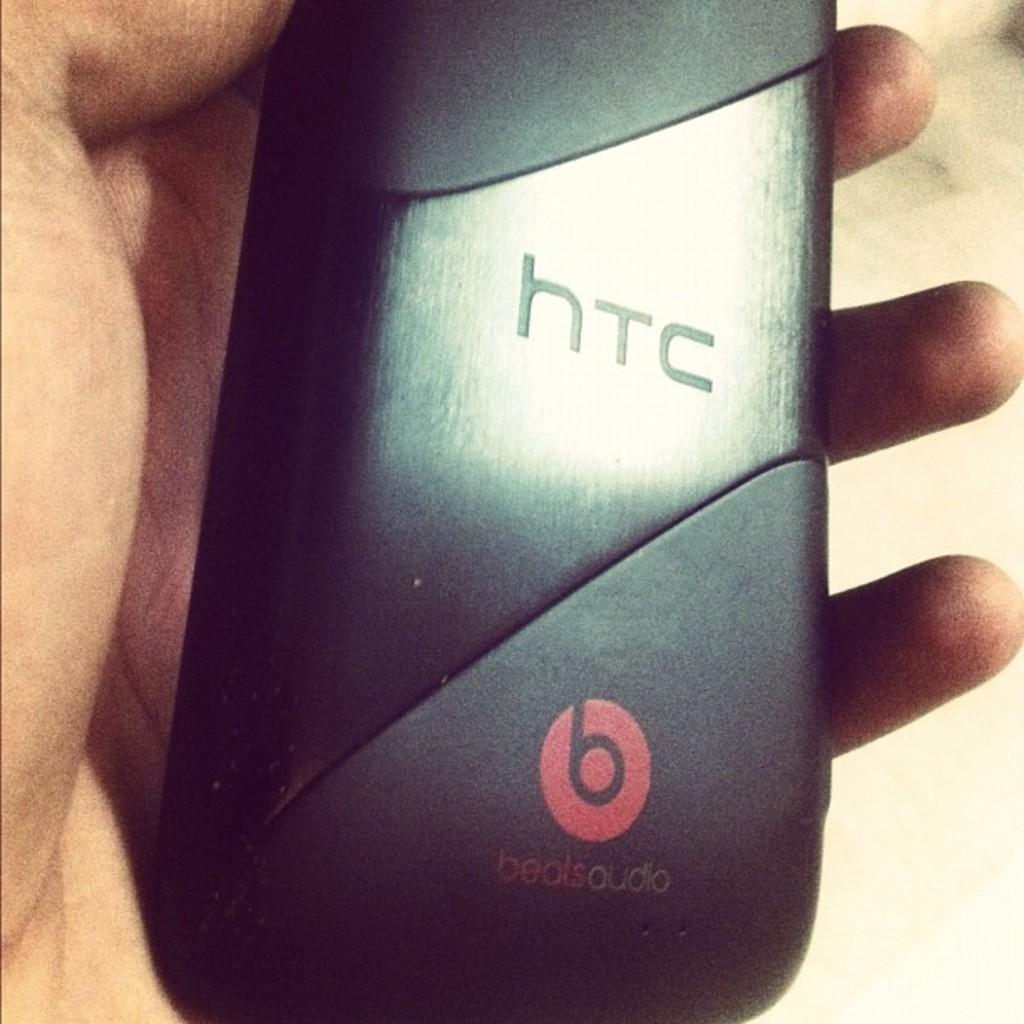Provide a one-sentence caption for the provided image. A man is holding a phone with the back facing to the camera showing that its an HTC phone. 